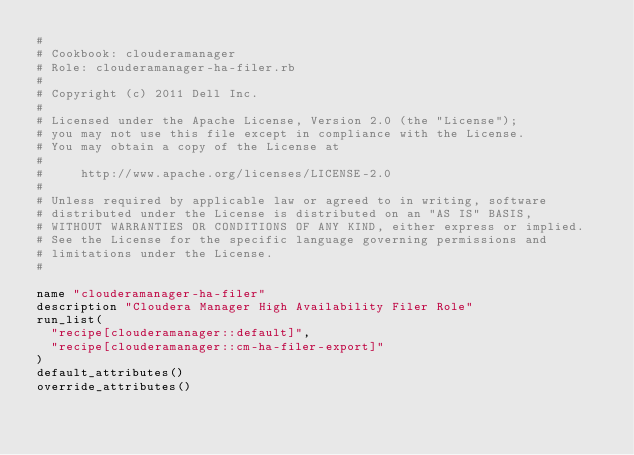<code> <loc_0><loc_0><loc_500><loc_500><_Ruby_>#
# Cookbook: clouderamanager
# Role: clouderamanager-ha-filer.rb
#
# Copyright (c) 2011 Dell Inc.
#
# Licensed under the Apache License, Version 2.0 (the "License");
# you may not use this file except in compliance with the License.
# You may obtain a copy of the License at
#
#     http://www.apache.org/licenses/LICENSE-2.0
#
# Unless required by applicable law or agreed to in writing, software
# distributed under the License is distributed on an "AS IS" BASIS,
# WITHOUT WARRANTIES OR CONDITIONS OF ANY KIND, either express or implied.
# See the License for the specific language governing permissions and
# limitations under the License.
#

name "clouderamanager-ha-filer"
description "Cloudera Manager High Availability Filer Role"
run_list(
  "recipe[clouderamanager::default]",
  "recipe[clouderamanager::cm-ha-filer-export]"
)
default_attributes()
override_attributes()
</code> 